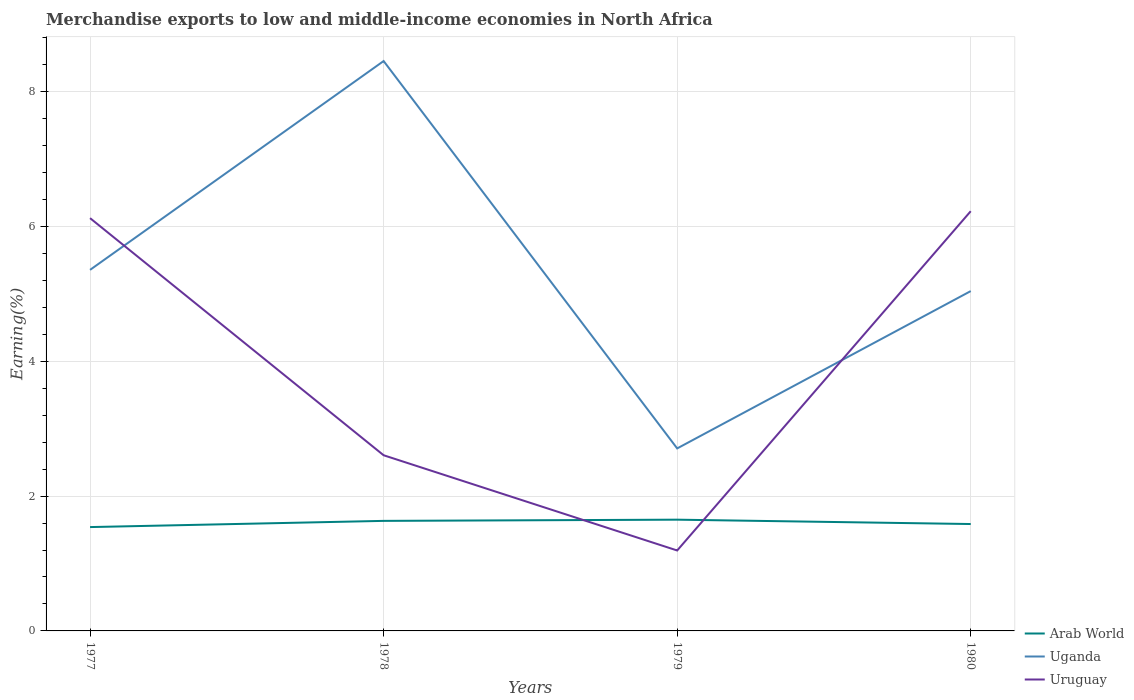How many different coloured lines are there?
Your answer should be compact. 3. Does the line corresponding to Arab World intersect with the line corresponding to Uganda?
Provide a succinct answer. No. Across all years, what is the maximum percentage of amount earned from merchandise exports in Uganda?
Your response must be concise. 2.71. In which year was the percentage of amount earned from merchandise exports in Arab World maximum?
Ensure brevity in your answer.  1977. What is the total percentage of amount earned from merchandise exports in Uganda in the graph?
Offer a terse response. -3.1. What is the difference between the highest and the second highest percentage of amount earned from merchandise exports in Arab World?
Provide a short and direct response. 0.11. What is the difference between the highest and the lowest percentage of amount earned from merchandise exports in Arab World?
Your answer should be compact. 2. How many lines are there?
Your answer should be very brief. 3. Are the values on the major ticks of Y-axis written in scientific E-notation?
Give a very brief answer. No. Where does the legend appear in the graph?
Offer a terse response. Bottom right. What is the title of the graph?
Ensure brevity in your answer.  Merchandise exports to low and middle-income economies in North Africa. What is the label or title of the Y-axis?
Make the answer very short. Earning(%). What is the Earning(%) in Arab World in 1977?
Your answer should be compact. 1.54. What is the Earning(%) in Uganda in 1977?
Keep it short and to the point. 5.36. What is the Earning(%) in Uruguay in 1977?
Keep it short and to the point. 6.12. What is the Earning(%) of Arab World in 1978?
Your answer should be very brief. 1.63. What is the Earning(%) of Uganda in 1978?
Offer a terse response. 8.45. What is the Earning(%) in Uruguay in 1978?
Ensure brevity in your answer.  2.61. What is the Earning(%) of Arab World in 1979?
Make the answer very short. 1.65. What is the Earning(%) in Uganda in 1979?
Your answer should be very brief. 2.71. What is the Earning(%) of Uruguay in 1979?
Your answer should be very brief. 1.19. What is the Earning(%) of Arab World in 1980?
Offer a very short reply. 1.59. What is the Earning(%) in Uganda in 1980?
Offer a terse response. 5.04. What is the Earning(%) in Uruguay in 1980?
Provide a short and direct response. 6.23. Across all years, what is the maximum Earning(%) in Arab World?
Ensure brevity in your answer.  1.65. Across all years, what is the maximum Earning(%) of Uganda?
Offer a terse response. 8.45. Across all years, what is the maximum Earning(%) of Uruguay?
Your answer should be compact. 6.23. Across all years, what is the minimum Earning(%) of Arab World?
Keep it short and to the point. 1.54. Across all years, what is the minimum Earning(%) of Uganda?
Give a very brief answer. 2.71. Across all years, what is the minimum Earning(%) in Uruguay?
Keep it short and to the point. 1.19. What is the total Earning(%) of Arab World in the graph?
Give a very brief answer. 6.41. What is the total Earning(%) of Uganda in the graph?
Your answer should be compact. 21.56. What is the total Earning(%) of Uruguay in the graph?
Offer a terse response. 16.15. What is the difference between the Earning(%) in Arab World in 1977 and that in 1978?
Your answer should be compact. -0.09. What is the difference between the Earning(%) in Uganda in 1977 and that in 1978?
Offer a very short reply. -3.1. What is the difference between the Earning(%) in Uruguay in 1977 and that in 1978?
Give a very brief answer. 3.52. What is the difference between the Earning(%) in Arab World in 1977 and that in 1979?
Make the answer very short. -0.11. What is the difference between the Earning(%) in Uganda in 1977 and that in 1979?
Offer a terse response. 2.65. What is the difference between the Earning(%) in Uruguay in 1977 and that in 1979?
Provide a succinct answer. 4.93. What is the difference between the Earning(%) of Arab World in 1977 and that in 1980?
Provide a succinct answer. -0.05. What is the difference between the Earning(%) in Uganda in 1977 and that in 1980?
Your answer should be compact. 0.31. What is the difference between the Earning(%) in Uruguay in 1977 and that in 1980?
Your response must be concise. -0.1. What is the difference between the Earning(%) in Arab World in 1978 and that in 1979?
Provide a succinct answer. -0.02. What is the difference between the Earning(%) of Uganda in 1978 and that in 1979?
Your answer should be compact. 5.75. What is the difference between the Earning(%) of Uruguay in 1978 and that in 1979?
Keep it short and to the point. 1.41. What is the difference between the Earning(%) in Arab World in 1978 and that in 1980?
Provide a short and direct response. 0.05. What is the difference between the Earning(%) of Uganda in 1978 and that in 1980?
Give a very brief answer. 3.41. What is the difference between the Earning(%) in Uruguay in 1978 and that in 1980?
Your response must be concise. -3.62. What is the difference between the Earning(%) in Arab World in 1979 and that in 1980?
Provide a succinct answer. 0.06. What is the difference between the Earning(%) of Uganda in 1979 and that in 1980?
Ensure brevity in your answer.  -2.33. What is the difference between the Earning(%) of Uruguay in 1979 and that in 1980?
Offer a very short reply. -5.03. What is the difference between the Earning(%) of Arab World in 1977 and the Earning(%) of Uganda in 1978?
Offer a very short reply. -6.91. What is the difference between the Earning(%) of Arab World in 1977 and the Earning(%) of Uruguay in 1978?
Offer a terse response. -1.07. What is the difference between the Earning(%) in Uganda in 1977 and the Earning(%) in Uruguay in 1978?
Give a very brief answer. 2.75. What is the difference between the Earning(%) in Arab World in 1977 and the Earning(%) in Uganda in 1979?
Make the answer very short. -1.17. What is the difference between the Earning(%) of Arab World in 1977 and the Earning(%) of Uruguay in 1979?
Keep it short and to the point. 0.35. What is the difference between the Earning(%) of Uganda in 1977 and the Earning(%) of Uruguay in 1979?
Offer a terse response. 4.16. What is the difference between the Earning(%) of Arab World in 1977 and the Earning(%) of Uganda in 1980?
Your answer should be compact. -3.5. What is the difference between the Earning(%) of Arab World in 1977 and the Earning(%) of Uruguay in 1980?
Make the answer very short. -4.69. What is the difference between the Earning(%) in Uganda in 1977 and the Earning(%) in Uruguay in 1980?
Ensure brevity in your answer.  -0.87. What is the difference between the Earning(%) in Arab World in 1978 and the Earning(%) in Uganda in 1979?
Provide a short and direct response. -1.07. What is the difference between the Earning(%) in Arab World in 1978 and the Earning(%) in Uruguay in 1979?
Your answer should be very brief. 0.44. What is the difference between the Earning(%) of Uganda in 1978 and the Earning(%) of Uruguay in 1979?
Provide a succinct answer. 7.26. What is the difference between the Earning(%) of Arab World in 1978 and the Earning(%) of Uganda in 1980?
Ensure brevity in your answer.  -3.41. What is the difference between the Earning(%) in Arab World in 1978 and the Earning(%) in Uruguay in 1980?
Your response must be concise. -4.59. What is the difference between the Earning(%) in Uganda in 1978 and the Earning(%) in Uruguay in 1980?
Provide a short and direct response. 2.23. What is the difference between the Earning(%) in Arab World in 1979 and the Earning(%) in Uganda in 1980?
Make the answer very short. -3.39. What is the difference between the Earning(%) in Arab World in 1979 and the Earning(%) in Uruguay in 1980?
Your response must be concise. -4.58. What is the difference between the Earning(%) in Uganda in 1979 and the Earning(%) in Uruguay in 1980?
Ensure brevity in your answer.  -3.52. What is the average Earning(%) of Arab World per year?
Provide a short and direct response. 1.6. What is the average Earning(%) in Uganda per year?
Give a very brief answer. 5.39. What is the average Earning(%) in Uruguay per year?
Give a very brief answer. 4.04. In the year 1977, what is the difference between the Earning(%) of Arab World and Earning(%) of Uganda?
Your answer should be compact. -3.82. In the year 1977, what is the difference between the Earning(%) of Arab World and Earning(%) of Uruguay?
Give a very brief answer. -4.58. In the year 1977, what is the difference between the Earning(%) in Uganda and Earning(%) in Uruguay?
Give a very brief answer. -0.77. In the year 1978, what is the difference between the Earning(%) in Arab World and Earning(%) in Uganda?
Your answer should be very brief. -6.82. In the year 1978, what is the difference between the Earning(%) of Arab World and Earning(%) of Uruguay?
Your answer should be compact. -0.97. In the year 1978, what is the difference between the Earning(%) of Uganda and Earning(%) of Uruguay?
Ensure brevity in your answer.  5.85. In the year 1979, what is the difference between the Earning(%) in Arab World and Earning(%) in Uganda?
Keep it short and to the point. -1.06. In the year 1979, what is the difference between the Earning(%) in Arab World and Earning(%) in Uruguay?
Your response must be concise. 0.46. In the year 1979, what is the difference between the Earning(%) of Uganda and Earning(%) of Uruguay?
Keep it short and to the point. 1.51. In the year 1980, what is the difference between the Earning(%) in Arab World and Earning(%) in Uganda?
Provide a succinct answer. -3.46. In the year 1980, what is the difference between the Earning(%) of Arab World and Earning(%) of Uruguay?
Make the answer very short. -4.64. In the year 1980, what is the difference between the Earning(%) of Uganda and Earning(%) of Uruguay?
Give a very brief answer. -1.19. What is the ratio of the Earning(%) of Arab World in 1977 to that in 1978?
Your answer should be compact. 0.94. What is the ratio of the Earning(%) of Uganda in 1977 to that in 1978?
Your response must be concise. 0.63. What is the ratio of the Earning(%) in Uruguay in 1977 to that in 1978?
Give a very brief answer. 2.35. What is the ratio of the Earning(%) in Arab World in 1977 to that in 1979?
Give a very brief answer. 0.93. What is the ratio of the Earning(%) of Uganda in 1977 to that in 1979?
Your response must be concise. 1.98. What is the ratio of the Earning(%) in Uruguay in 1977 to that in 1979?
Your response must be concise. 5.13. What is the ratio of the Earning(%) in Arab World in 1977 to that in 1980?
Give a very brief answer. 0.97. What is the ratio of the Earning(%) in Uruguay in 1977 to that in 1980?
Provide a succinct answer. 0.98. What is the ratio of the Earning(%) in Arab World in 1978 to that in 1979?
Give a very brief answer. 0.99. What is the ratio of the Earning(%) of Uganda in 1978 to that in 1979?
Offer a terse response. 3.12. What is the ratio of the Earning(%) of Uruguay in 1978 to that in 1979?
Your response must be concise. 2.18. What is the ratio of the Earning(%) in Arab World in 1978 to that in 1980?
Offer a terse response. 1.03. What is the ratio of the Earning(%) in Uganda in 1978 to that in 1980?
Offer a terse response. 1.68. What is the ratio of the Earning(%) of Uruguay in 1978 to that in 1980?
Your answer should be compact. 0.42. What is the ratio of the Earning(%) of Arab World in 1979 to that in 1980?
Your response must be concise. 1.04. What is the ratio of the Earning(%) in Uganda in 1979 to that in 1980?
Your response must be concise. 0.54. What is the ratio of the Earning(%) in Uruguay in 1979 to that in 1980?
Offer a very short reply. 0.19. What is the difference between the highest and the second highest Earning(%) in Arab World?
Keep it short and to the point. 0.02. What is the difference between the highest and the second highest Earning(%) in Uganda?
Offer a terse response. 3.1. What is the difference between the highest and the second highest Earning(%) of Uruguay?
Give a very brief answer. 0.1. What is the difference between the highest and the lowest Earning(%) of Arab World?
Your answer should be compact. 0.11. What is the difference between the highest and the lowest Earning(%) in Uganda?
Your answer should be compact. 5.75. What is the difference between the highest and the lowest Earning(%) in Uruguay?
Offer a very short reply. 5.03. 